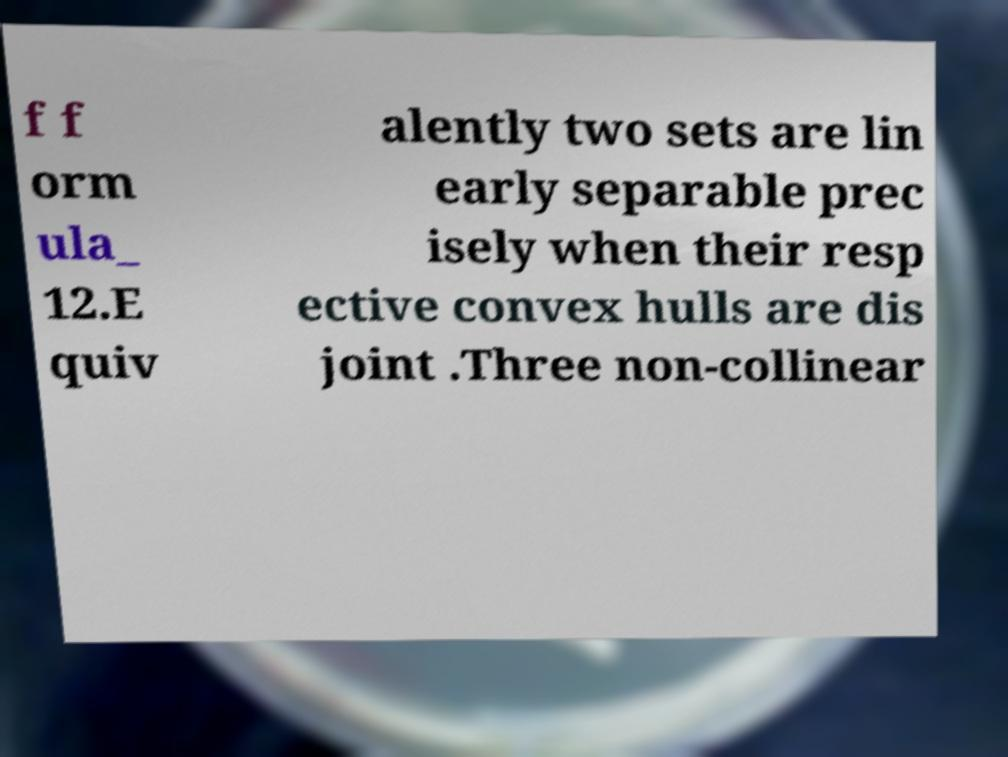What messages or text are displayed in this image? I need them in a readable, typed format. f f orm ula_ 12.E quiv alently two sets are lin early separable prec isely when their resp ective convex hulls are dis joint .Three non-collinear 